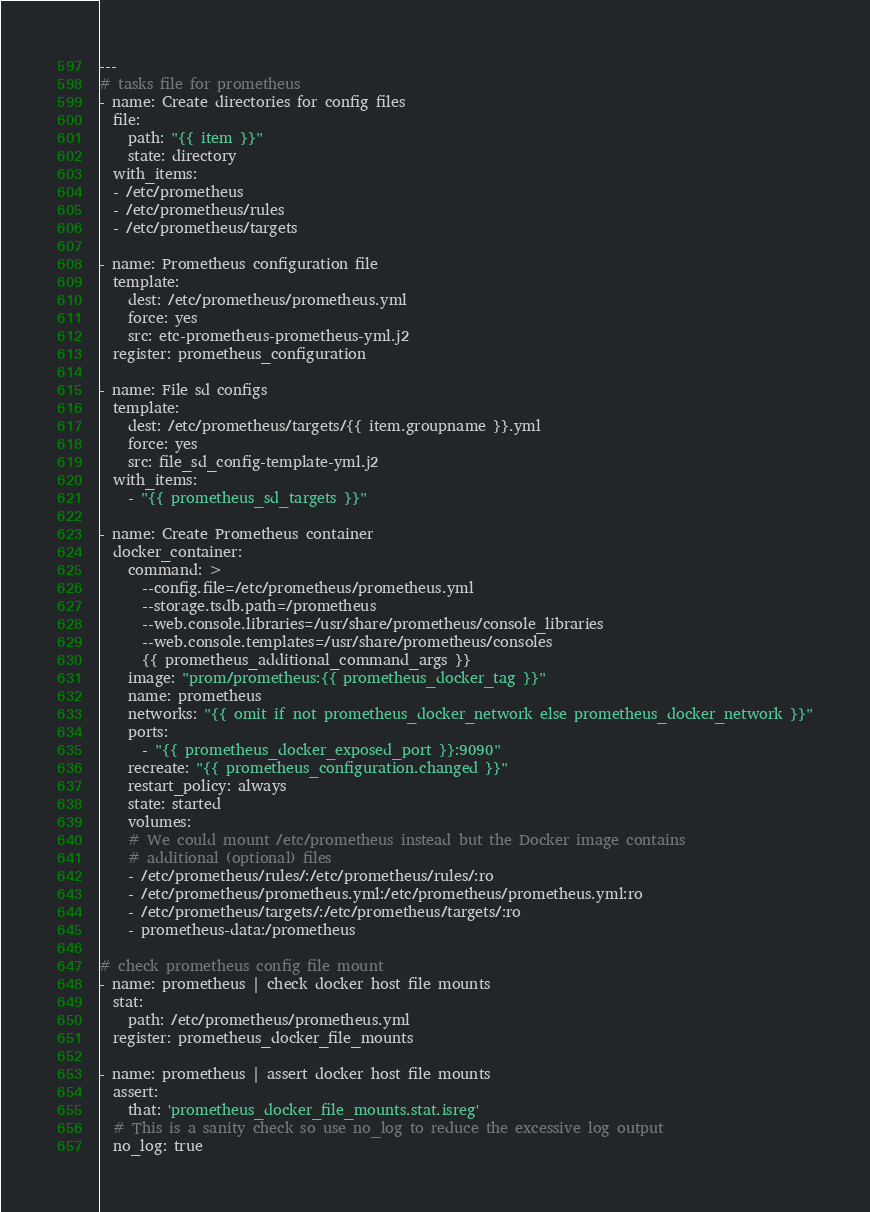Convert code to text. <code><loc_0><loc_0><loc_500><loc_500><_YAML_>---
# tasks file for prometheus
- name: Create directories for config files
  file:
    path: "{{ item }}"
    state: directory
  with_items:
  - /etc/prometheus
  - /etc/prometheus/rules
  - /etc/prometheus/targets

- name: Prometheus configuration file
  template:
    dest: /etc/prometheus/prometheus.yml
    force: yes
    src: etc-prometheus-prometheus-yml.j2
  register: prometheus_configuration

- name: File sd configs
  template:
    dest: /etc/prometheus/targets/{{ item.groupname }}.yml
    force: yes
    src: file_sd_config-template-yml.j2
  with_items:
    - "{{ prometheus_sd_targets }}"

- name: Create Prometheus container
  docker_container:
    command: >
      --config.file=/etc/prometheus/prometheus.yml
      --storage.tsdb.path=/prometheus
      --web.console.libraries=/usr/share/prometheus/console_libraries
      --web.console.templates=/usr/share/prometheus/consoles
      {{ prometheus_additional_command_args }}
    image: "prom/prometheus:{{ prometheus_docker_tag }}"
    name: prometheus
    networks: "{{ omit if not prometheus_docker_network else prometheus_docker_network }}"
    ports:
      - "{{ prometheus_docker_exposed_port }}:9090"
    recreate: "{{ prometheus_configuration.changed }}"
    restart_policy: always
    state: started
    volumes:
    # We could mount /etc/prometheus instead but the Docker image contains
    # additional (optional) files
    - /etc/prometheus/rules/:/etc/prometheus/rules/:ro
    - /etc/prometheus/prometheus.yml:/etc/prometheus/prometheus.yml:ro
    - /etc/prometheus/targets/:/etc/prometheus/targets/:ro
    - prometheus-data:/prometheus

# check prometheus config file mount
- name: prometheus | check docker host file mounts
  stat:
    path: /etc/prometheus/prometheus.yml
  register: prometheus_docker_file_mounts

- name: prometheus | assert docker host file mounts
  assert:
    that: 'prometheus_docker_file_mounts.stat.isreg'
  # This is a sanity check so use no_log to reduce the excessive log output
  no_log: true
</code> 